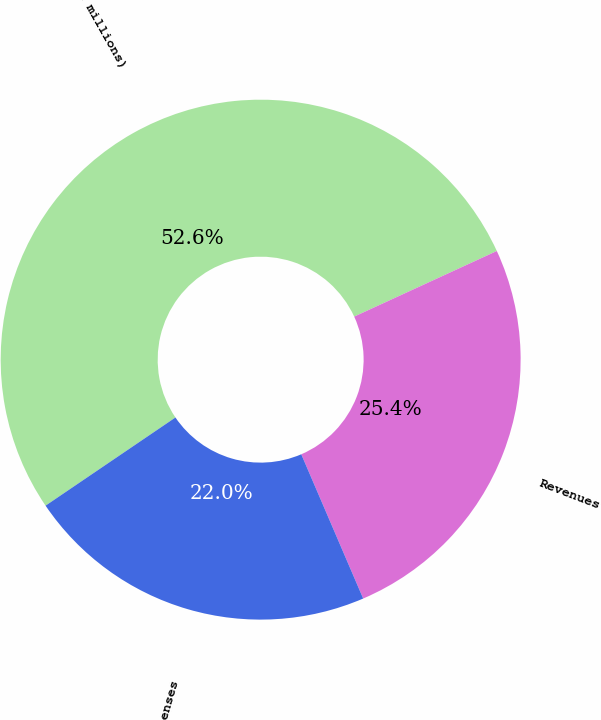Convert chart. <chart><loc_0><loc_0><loc_500><loc_500><pie_chart><fcel>(in millions)<fcel>Revenues<fcel>Expenses<nl><fcel>52.63%<fcel>25.41%<fcel>21.96%<nl></chart> 